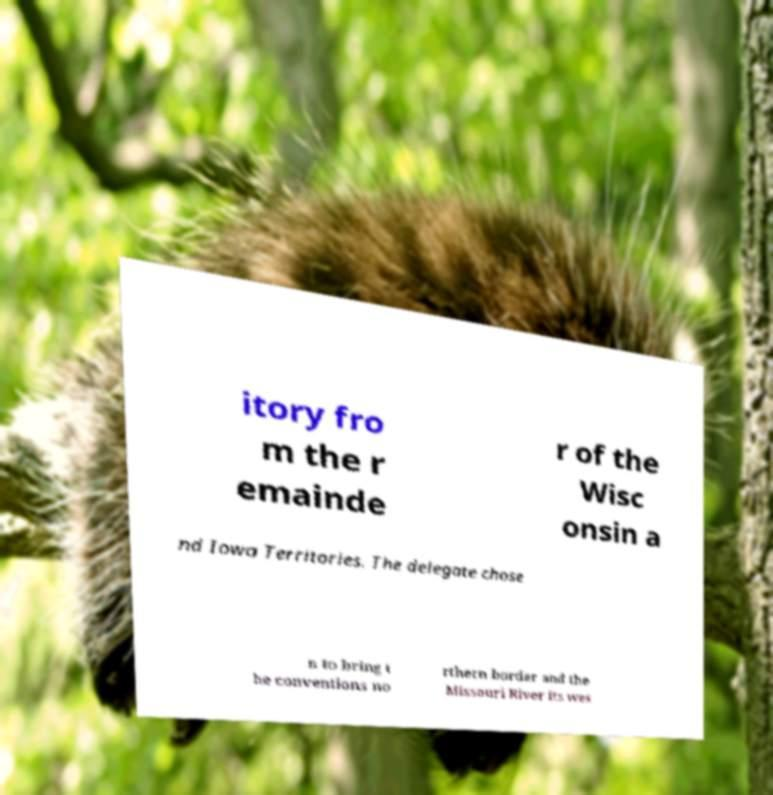For documentation purposes, I need the text within this image transcribed. Could you provide that? itory fro m the r emainde r of the Wisc onsin a nd Iowa Territories. The delegate chose n to bring t he conventions no rthern border and the Missouri River its wes 